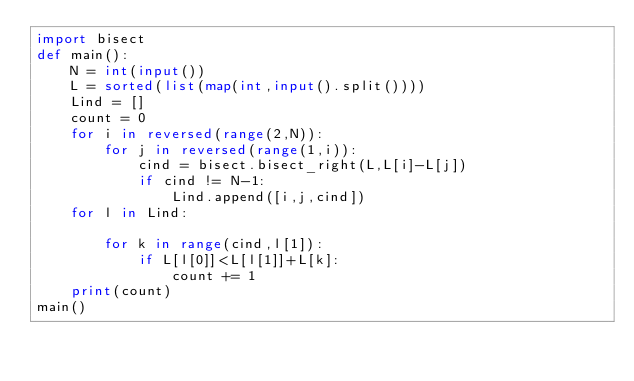Convert code to text. <code><loc_0><loc_0><loc_500><loc_500><_Python_>import bisect
def main():
    N = int(input())
    L = sorted(list(map(int,input().split())))
    Lind = []
    count = 0
    for i in reversed(range(2,N)):
        for j in reversed(range(1,i)):
            cind = bisect.bisect_right(L,L[i]-L[j])
            if cind != N-1:
                Lind.append([i,j,cind])
    for l in Lind:
        
        for k in range(cind,l[1]):
            if L[l[0]]<L[l[1]]+L[k]:
                count += 1
    print(count)
main()</code> 